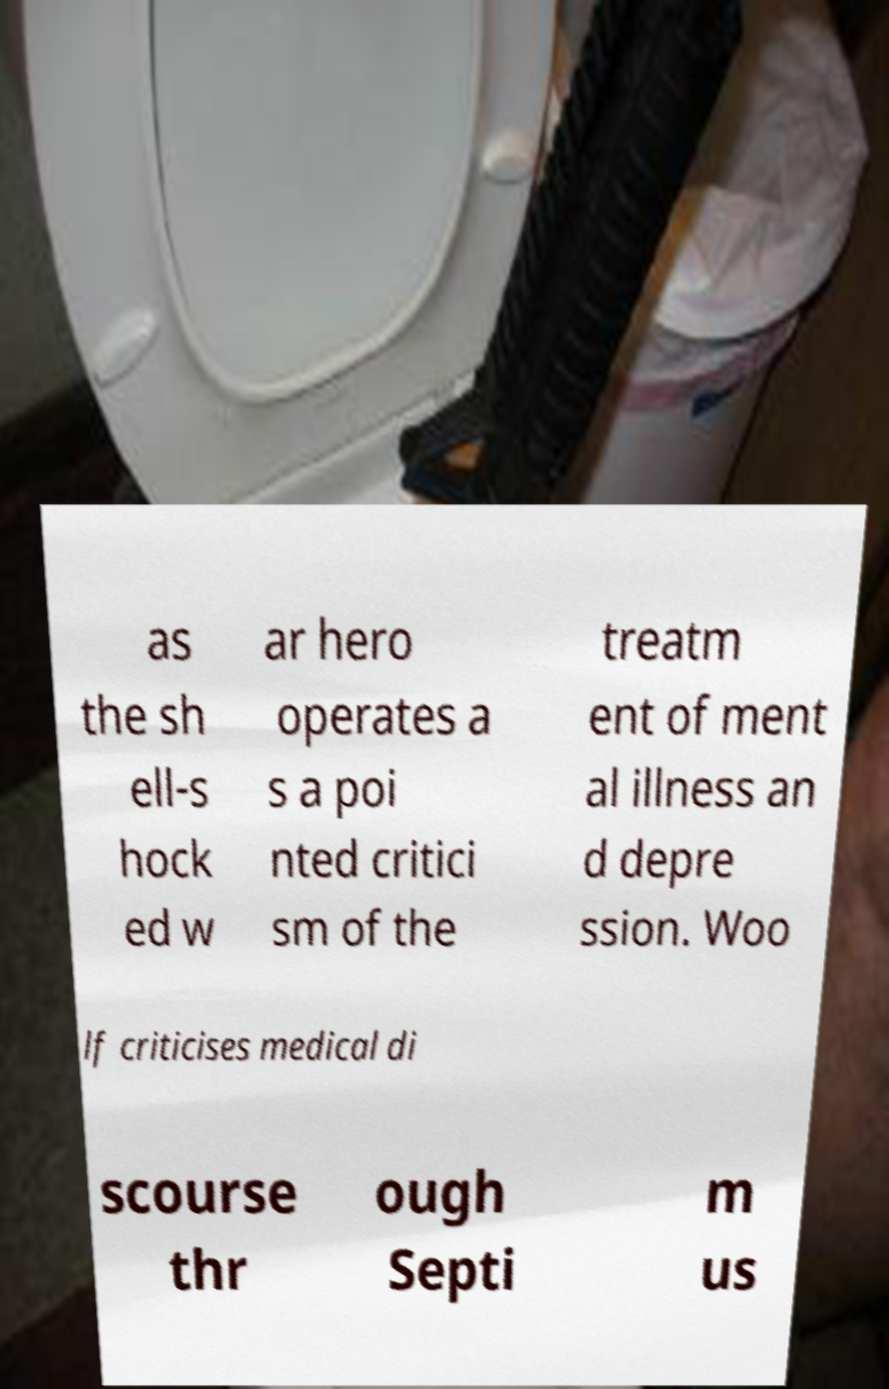What messages or text are displayed in this image? I need them in a readable, typed format. as the sh ell-s hock ed w ar hero operates a s a poi nted critici sm of the treatm ent of ment al illness an d depre ssion. Woo lf criticises medical di scourse thr ough Septi m us 